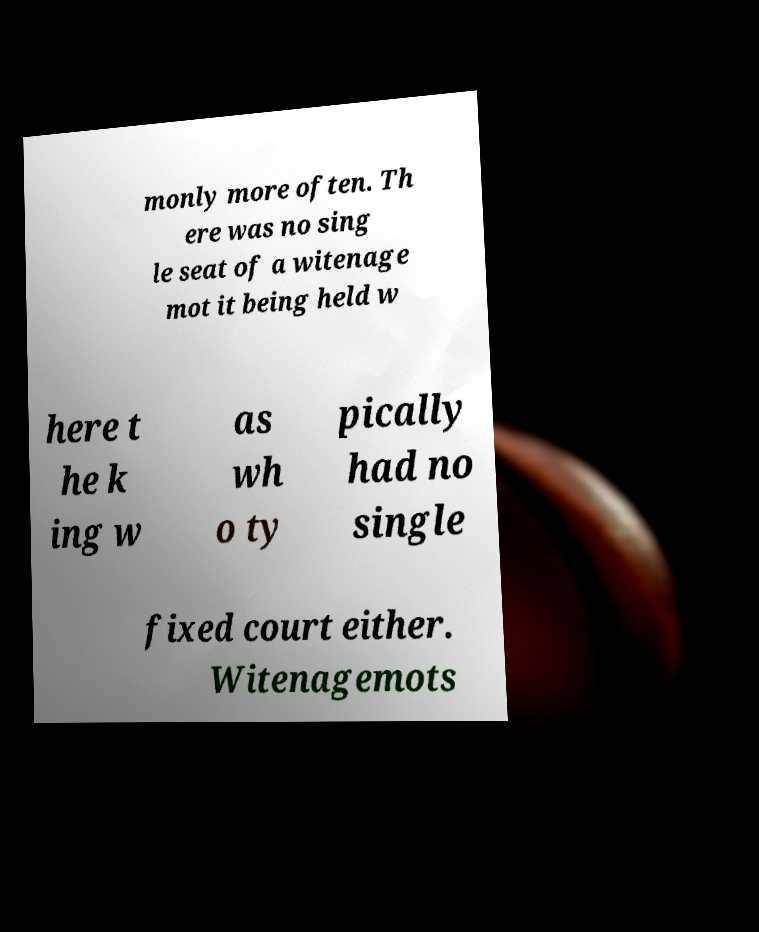Could you assist in decoding the text presented in this image and type it out clearly? monly more often. Th ere was no sing le seat of a witenage mot it being held w here t he k ing w as wh o ty pically had no single fixed court either. Witenagemots 